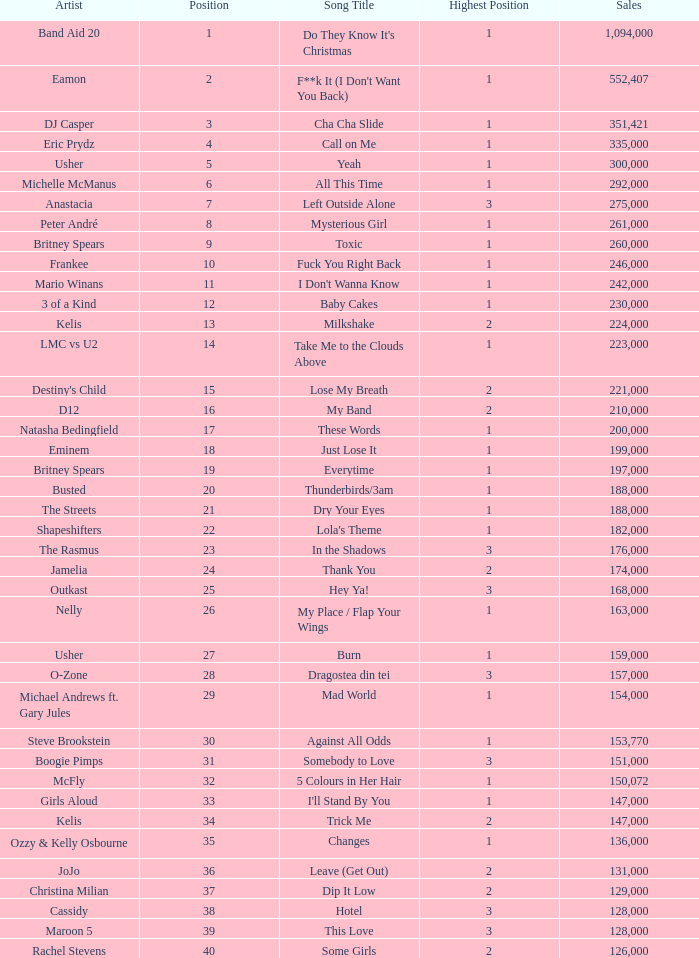What were the sales for Dj Casper when he was in a position lower than 13? 351421.0. 